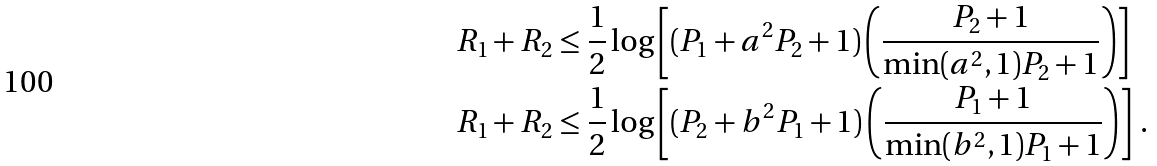<formula> <loc_0><loc_0><loc_500><loc_500>R _ { 1 } + R _ { 2 } & \leq \frac { 1 } { 2 } \log \left [ ( P _ { 1 } + a ^ { 2 } P _ { 2 } + 1 ) \left ( \frac { P _ { 2 } + 1 } { \min ( a ^ { 2 } , 1 ) P _ { 2 } + 1 } \right ) \right ] \\ R _ { 1 } + R _ { 2 } & \leq \frac { 1 } { 2 } \log \left [ ( P _ { 2 } + b ^ { 2 } P _ { 1 } + 1 ) \left ( \frac { P _ { 1 } + 1 } { \min ( b ^ { 2 } , 1 ) P _ { 1 } + 1 } \right ) \right ] \, .</formula> 